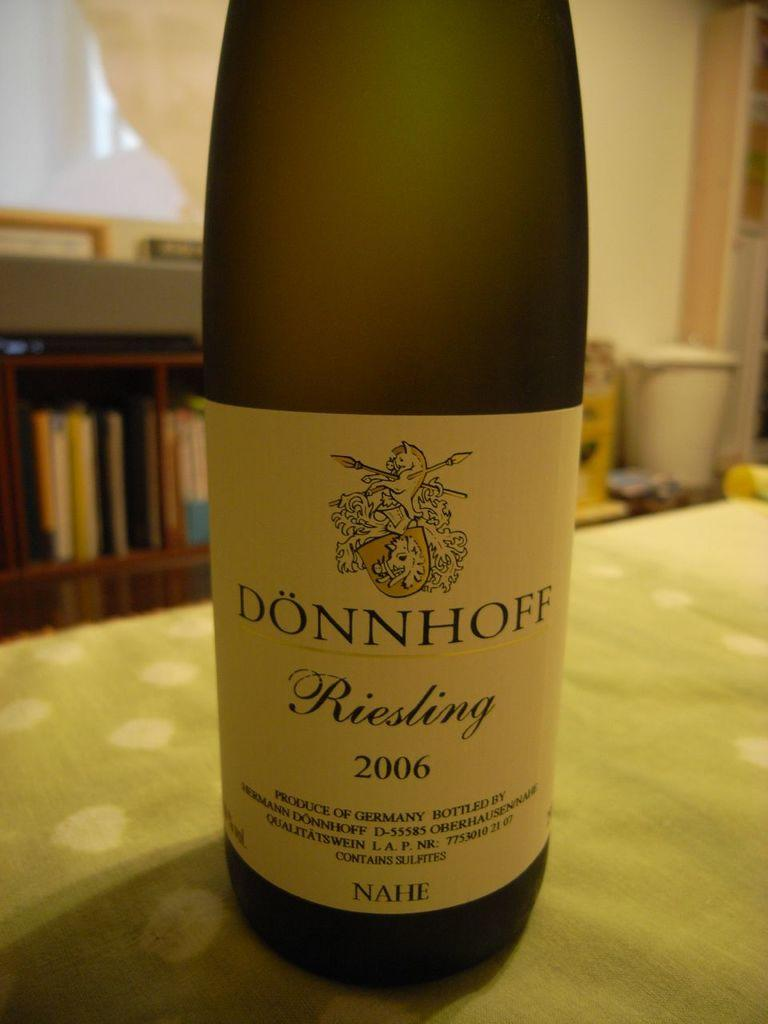Provide a one-sentence caption for the provided image. A bottle of Donnhoff wine stands on a kitchen table. 